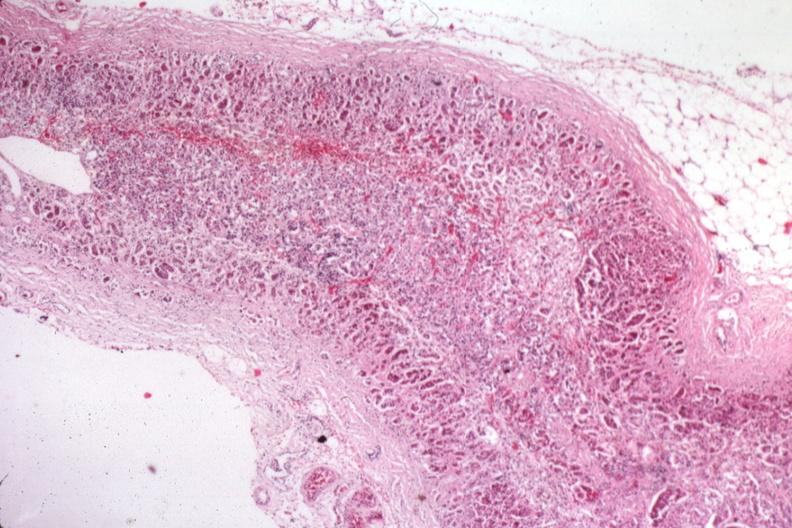s endocrine present?
Answer the question using a single word or phrase. Yes 